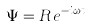<formula> <loc_0><loc_0><loc_500><loc_500>\Psi = R \, e ^ { - i \omega t }</formula> 